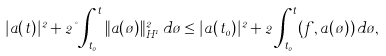Convert formula to latex. <formula><loc_0><loc_0><loc_500><loc_500>| a ( t ) | ^ { 2 } + 2 \nu \int _ { t _ { 0 } } ^ { t } \| a ( \tau ) \| _ { H ^ { 1 } } ^ { 2 } \, d \tau \leq | a ( t _ { 0 } ) | ^ { 2 } + 2 \int _ { t _ { 0 } } ^ { t } ( f , a ( \tau ) ) \, d \tau ,</formula> 